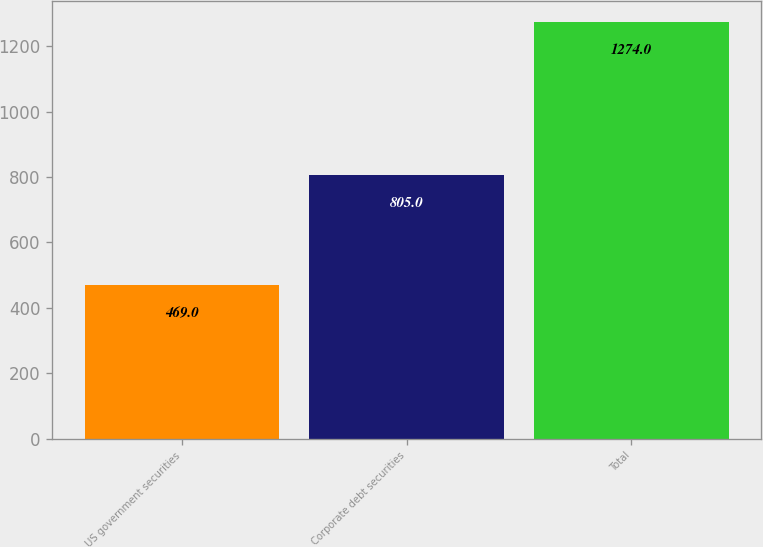<chart> <loc_0><loc_0><loc_500><loc_500><bar_chart><fcel>US government securities<fcel>Corporate debt securities<fcel>Total<nl><fcel>469<fcel>805<fcel>1274<nl></chart> 